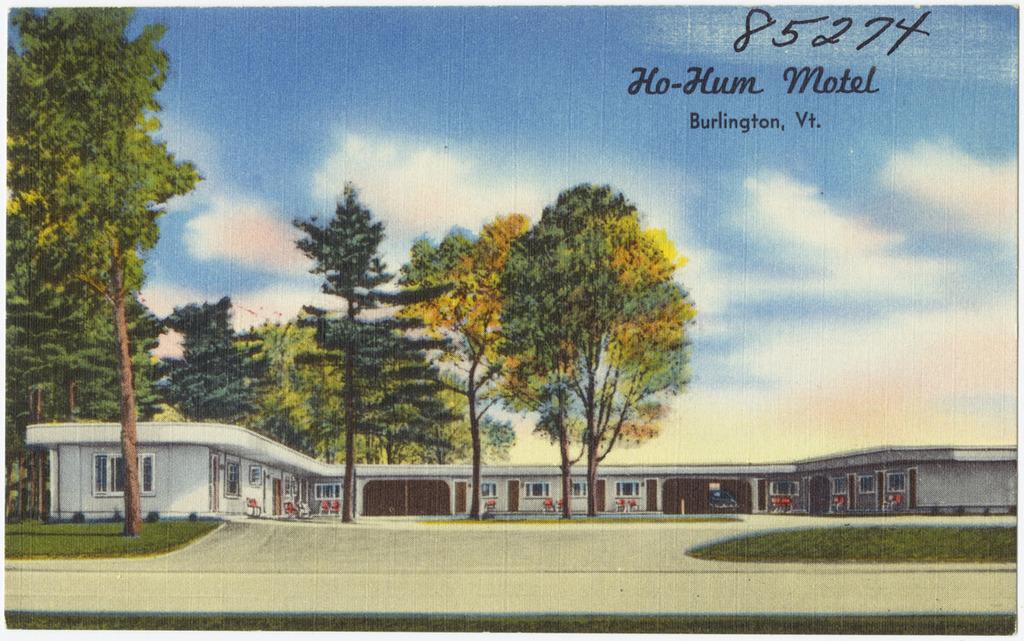Where is this postcard featuring?
Give a very brief answer. Ho-hum motel. 